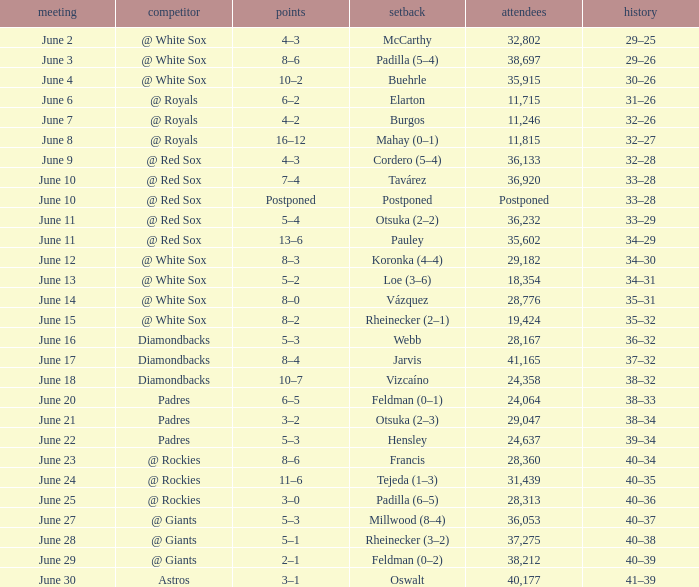When did tavárez lose? June 10. 